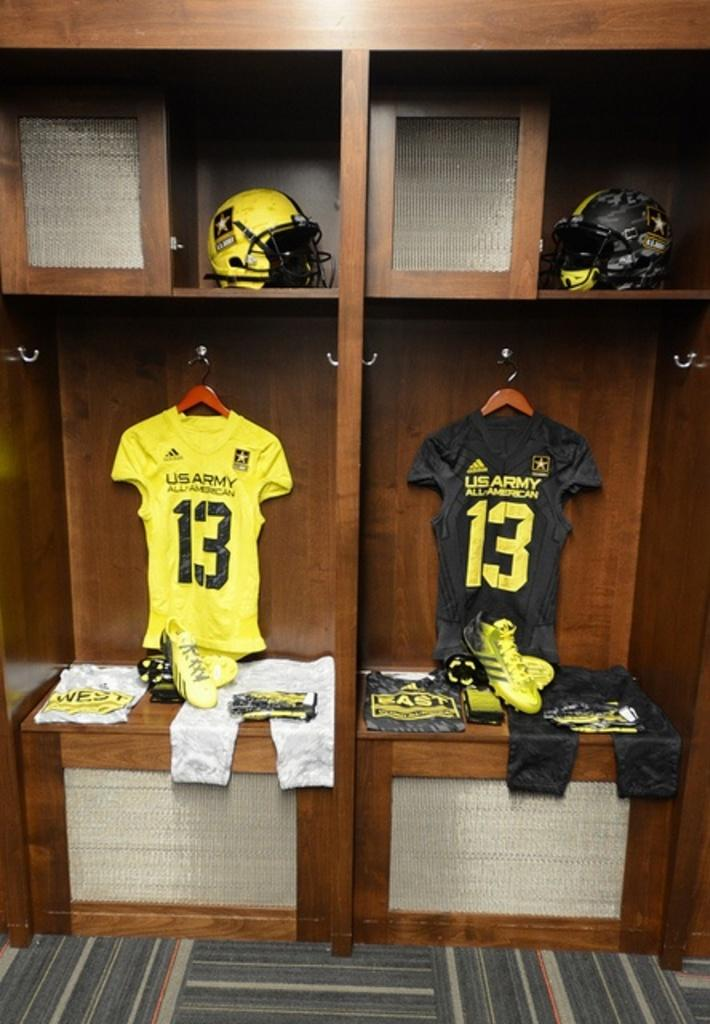<image>
Share a concise interpretation of the image provided. US Army All American number 13 football uniforms and helmets in black and yellow are displayed in wooden lockers. 